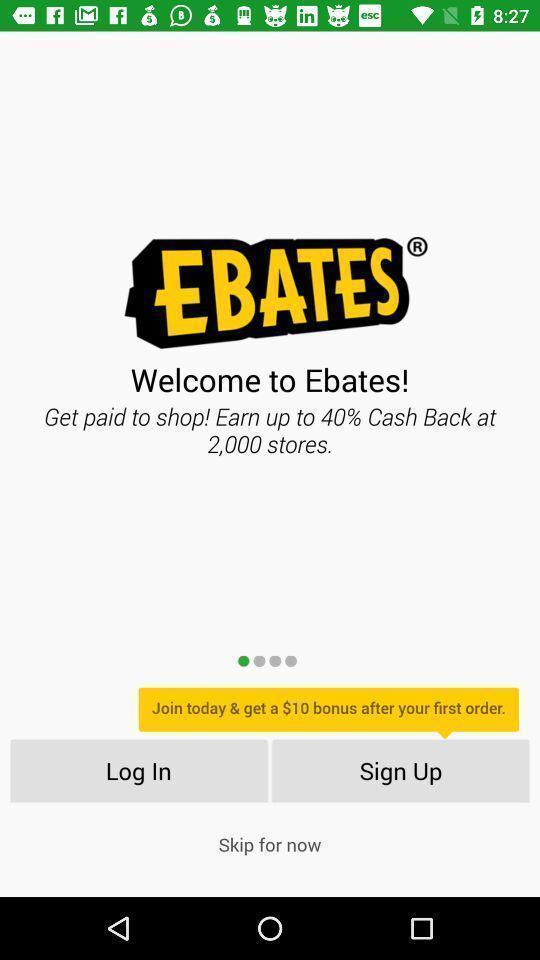Give me a summary of this screen capture. Sign up page. 